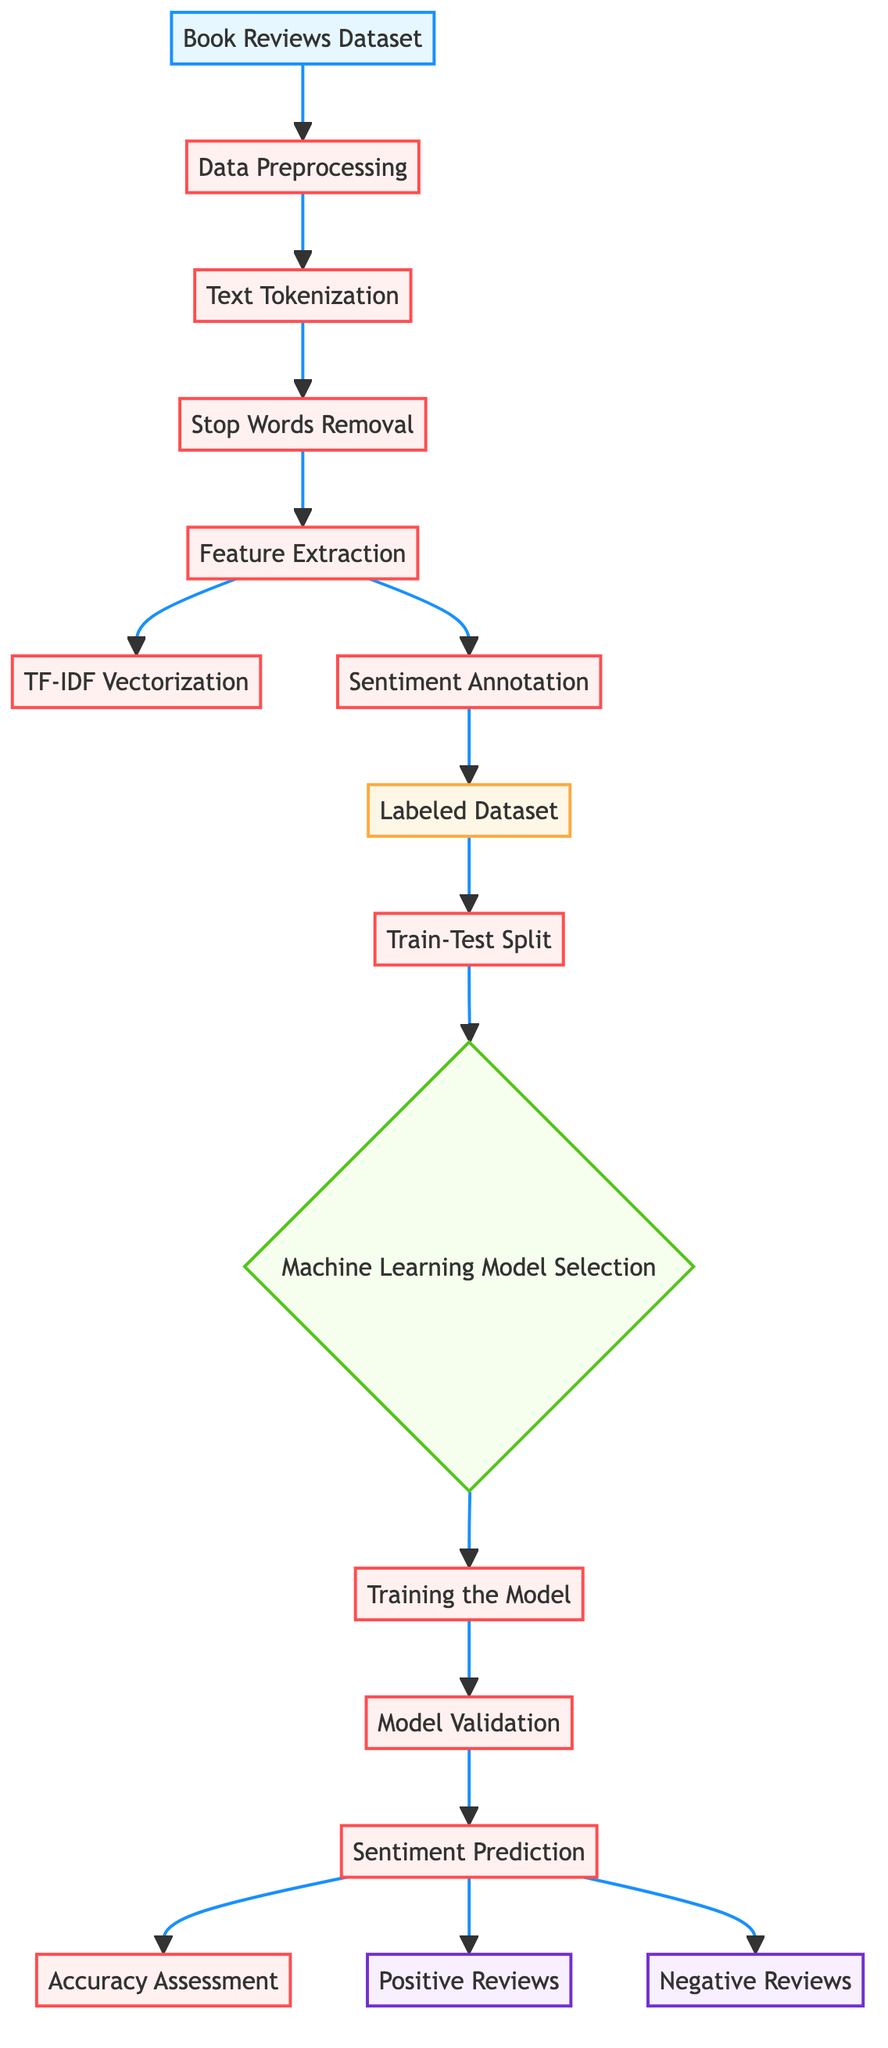What's the first step in the diagram? The diagram starts with the node labeled "Book Reviews Dataset," which represents the initial data source for the analysis process.
Answer: Book Reviews Dataset How many processes are shown in the diagram? By counting all the nodes labeled as processes, we find there are six distinct processes: Data Preprocessing, Text Tokenization, Stop Words Removal, Feature Extraction, TF-IDF Vectorization, and Sentiment Annotation.
Answer: Six What happens after "Sentiment Annotation"? Following the "Sentiment Annotation" node, the next step is the creation of a "Labeled Dataset," which indicates that the dataset is now ready for further usage in the model training process.
Answer: Labeled Dataset What type of outputs are generated from the sentiment prediction? The final output nodes from "Sentiment Prediction" indicate there are two sentiment classifications, namely "Positive Reviews" and "Negative Reviews," representing the analysis results.
Answer: Positive Reviews and Negative Reviews What is the immediate process after "Feature Extraction"? Immediately after "Feature Extraction," the step is "TF-IDF Vectorization," which focuses on representing the extracted features in a numerical format suitable for machine learning models.
Answer: TF-IDF Vectorization Which processes lead directly to the "Train-Test Split"? The "Labeled Dataset" directly leads to "Train-Test Split," establishing that only datasets with labels are split for training and testing phases.
Answer: Labeled Dataset What decision is made after the "Train-Test Split"? After the "Train-Test Split," a decision is made regarding the "Machine Learning Model Selection," suggesting that a model is to be chosen for training on the dataset.
Answer: Machine Learning Model Selection What process follows "Model Validation"? Following "Model Validation," the next step is "Sentiment Prediction," indicating that after validating the model, its predictive capabilities are utilized to analyze sentiment.
Answer: Sentiment Prediction What types of data transformations occur before the model selection? Before the model selection, a range of data preprocessing transformations occur, including text tokenization, stop words removal, feature extraction, and TF-IDF vectorization, all crucial for preparing the text data.
Answer: Text Tokenization, Stop Words Removal, Feature Extraction, TF-IDF Vectorization 